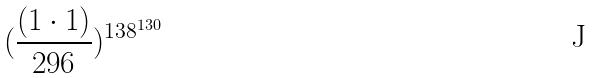Convert formula to latex. <formula><loc_0><loc_0><loc_500><loc_500>( \frac { ( 1 \cdot 1 ) } { 2 9 6 } ) ^ { 1 3 8 ^ { 1 3 0 } }</formula> 